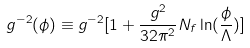<formula> <loc_0><loc_0><loc_500><loc_500>g ^ { - 2 } ( \phi ) \equiv g ^ { - 2 } [ 1 + \frac { g ^ { 2 } } { 3 2 \pi ^ { 2 } } N _ { f } \ln ( \frac { \phi } { \Lambda } ) ]</formula> 